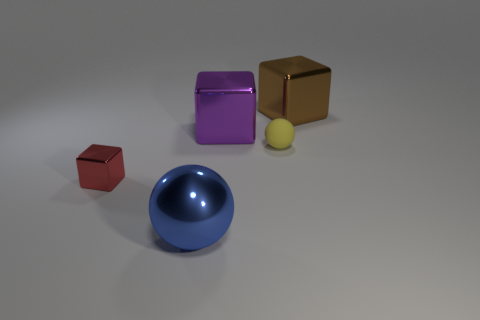Do these objects have any real-world applications? Yes, these shapes can represent various real-world applications. For instance, a cube could symbolize traditional dice or a storage box. Thesphere could be a model of a ball bearing element, and the cylinder might stand for a variety of objects, such as a container or a drum. In educational contexts, these shapes are often used as teaching aids to help students understand geometry and spatial relations. 